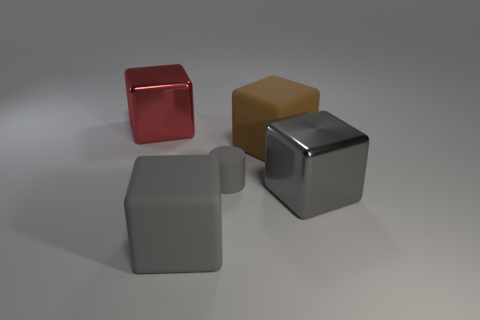Subtract all red blocks. How many blocks are left? 3 Add 3 big gray things. How many objects exist? 8 Subtract all gray cubes. How many cubes are left? 2 Subtract 1 cylinders. How many cylinders are left? 0 Subtract all cubes. How many objects are left? 1 Subtract all blue cubes. Subtract all yellow cylinders. How many cubes are left? 4 Subtract all blue balls. How many red cubes are left? 1 Subtract all small gray objects. Subtract all tiny gray cylinders. How many objects are left? 3 Add 2 brown matte blocks. How many brown matte blocks are left? 3 Add 1 large gray metallic blocks. How many large gray metallic blocks exist? 2 